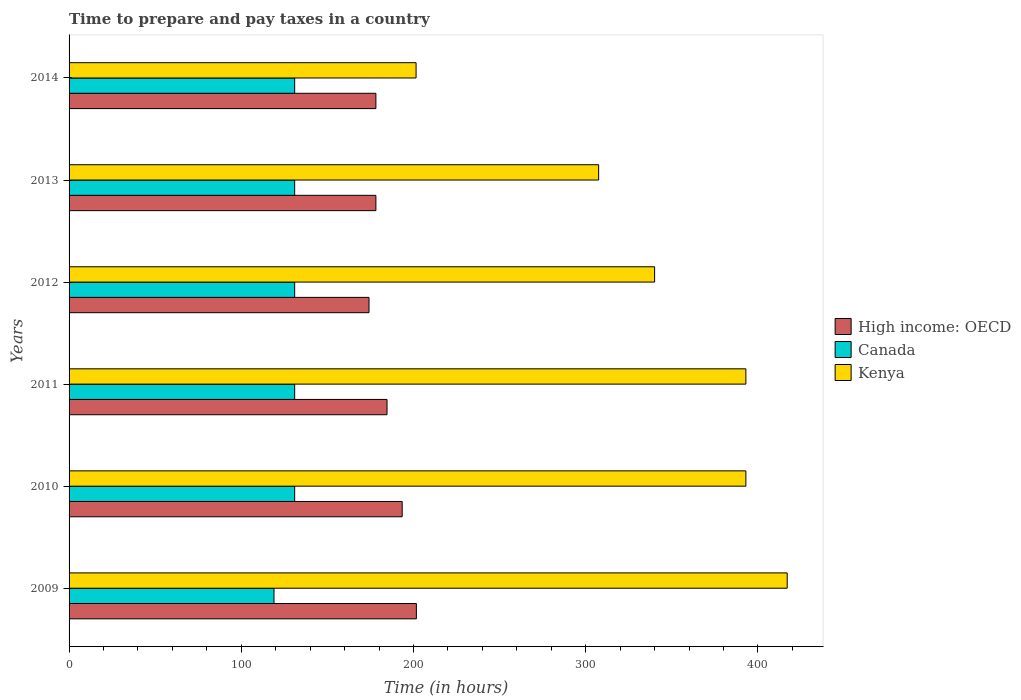How many groups of bars are there?
Ensure brevity in your answer.  6. How many bars are there on the 4th tick from the top?
Your response must be concise. 3. What is the number of hours required to prepare and pay taxes in High income: OECD in 2012?
Make the answer very short. 174.17. Across all years, what is the maximum number of hours required to prepare and pay taxes in High income: OECD?
Ensure brevity in your answer.  201.67. Across all years, what is the minimum number of hours required to prepare and pay taxes in High income: OECD?
Your answer should be very brief. 174.17. In which year was the number of hours required to prepare and pay taxes in Kenya maximum?
Your answer should be very brief. 2009. What is the total number of hours required to prepare and pay taxes in Kenya in the graph?
Offer a terse response. 2052. What is the difference between the number of hours required to prepare and pay taxes in High income: OECD in 2012 and that in 2014?
Provide a short and direct response. -3.99. What is the difference between the number of hours required to prepare and pay taxes in Canada in 2009 and the number of hours required to prepare and pay taxes in Kenya in 2011?
Provide a succinct answer. -274. What is the average number of hours required to prepare and pay taxes in Canada per year?
Give a very brief answer. 129. In the year 2013, what is the difference between the number of hours required to prepare and pay taxes in Canada and number of hours required to prepare and pay taxes in Kenya?
Give a very brief answer. -176.5. What is the ratio of the number of hours required to prepare and pay taxes in High income: OECD in 2009 to that in 2013?
Make the answer very short. 1.13. What is the difference between the highest and the second highest number of hours required to prepare and pay taxes in Canada?
Provide a succinct answer. 0. What is the difference between the highest and the lowest number of hours required to prepare and pay taxes in High income: OECD?
Ensure brevity in your answer.  27.5. In how many years, is the number of hours required to prepare and pay taxes in Kenya greater than the average number of hours required to prepare and pay taxes in Kenya taken over all years?
Provide a succinct answer. 3. Is the sum of the number of hours required to prepare and pay taxes in Kenya in 2011 and 2013 greater than the maximum number of hours required to prepare and pay taxes in High income: OECD across all years?
Your response must be concise. Yes. What does the 3rd bar from the top in 2009 represents?
Offer a terse response. High income: OECD. What does the 3rd bar from the bottom in 2013 represents?
Offer a terse response. Kenya. How many years are there in the graph?
Your answer should be compact. 6. What is the difference between two consecutive major ticks on the X-axis?
Offer a very short reply. 100. Are the values on the major ticks of X-axis written in scientific E-notation?
Give a very brief answer. No. Does the graph contain any zero values?
Give a very brief answer. No. Does the graph contain grids?
Provide a succinct answer. No. Where does the legend appear in the graph?
Your answer should be compact. Center right. How many legend labels are there?
Offer a very short reply. 3. What is the title of the graph?
Your answer should be compact. Time to prepare and pay taxes in a country. What is the label or title of the X-axis?
Provide a short and direct response. Time (in hours). What is the label or title of the Y-axis?
Your answer should be compact. Years. What is the Time (in hours) of High income: OECD in 2009?
Ensure brevity in your answer.  201.67. What is the Time (in hours) in Canada in 2009?
Offer a very short reply. 119. What is the Time (in hours) in Kenya in 2009?
Make the answer very short. 417. What is the Time (in hours) in High income: OECD in 2010?
Provide a short and direct response. 193.43. What is the Time (in hours) of Canada in 2010?
Provide a short and direct response. 131. What is the Time (in hours) in Kenya in 2010?
Provide a succinct answer. 393. What is the Time (in hours) of High income: OECD in 2011?
Give a very brief answer. 184.63. What is the Time (in hours) in Canada in 2011?
Your response must be concise. 131. What is the Time (in hours) of Kenya in 2011?
Ensure brevity in your answer.  393. What is the Time (in hours) in High income: OECD in 2012?
Your answer should be compact. 174.17. What is the Time (in hours) in Canada in 2012?
Your answer should be compact. 131. What is the Time (in hours) of Kenya in 2012?
Your response must be concise. 340. What is the Time (in hours) of High income: OECD in 2013?
Provide a short and direct response. 178.16. What is the Time (in hours) of Canada in 2013?
Keep it short and to the point. 131. What is the Time (in hours) of Kenya in 2013?
Your answer should be very brief. 307.5. What is the Time (in hours) of High income: OECD in 2014?
Your answer should be compact. 178.16. What is the Time (in hours) in Canada in 2014?
Your response must be concise. 131. What is the Time (in hours) of Kenya in 2014?
Provide a succinct answer. 201.5. Across all years, what is the maximum Time (in hours) in High income: OECD?
Provide a succinct answer. 201.67. Across all years, what is the maximum Time (in hours) of Canada?
Provide a short and direct response. 131. Across all years, what is the maximum Time (in hours) in Kenya?
Your response must be concise. 417. Across all years, what is the minimum Time (in hours) in High income: OECD?
Your response must be concise. 174.17. Across all years, what is the minimum Time (in hours) of Canada?
Provide a succinct answer. 119. Across all years, what is the minimum Time (in hours) in Kenya?
Offer a very short reply. 201.5. What is the total Time (in hours) of High income: OECD in the graph?
Offer a very short reply. 1110.21. What is the total Time (in hours) in Canada in the graph?
Offer a terse response. 774. What is the total Time (in hours) of Kenya in the graph?
Provide a succinct answer. 2052. What is the difference between the Time (in hours) of High income: OECD in 2009 and that in 2010?
Keep it short and to the point. 8.23. What is the difference between the Time (in hours) of Canada in 2009 and that in 2010?
Your answer should be compact. -12. What is the difference between the Time (in hours) in Kenya in 2009 and that in 2010?
Give a very brief answer. 24. What is the difference between the Time (in hours) of High income: OECD in 2009 and that in 2011?
Your answer should be compact. 17.03. What is the difference between the Time (in hours) in Canada in 2009 and that in 2011?
Your answer should be very brief. -12. What is the difference between the Time (in hours) of High income: OECD in 2009 and that in 2012?
Your answer should be very brief. 27.5. What is the difference between the Time (in hours) of Canada in 2009 and that in 2012?
Offer a very short reply. -12. What is the difference between the Time (in hours) in High income: OECD in 2009 and that in 2013?
Provide a short and direct response. 23.51. What is the difference between the Time (in hours) of Canada in 2009 and that in 2013?
Give a very brief answer. -12. What is the difference between the Time (in hours) in Kenya in 2009 and that in 2013?
Your answer should be very brief. 109.5. What is the difference between the Time (in hours) in High income: OECD in 2009 and that in 2014?
Ensure brevity in your answer.  23.51. What is the difference between the Time (in hours) of Canada in 2009 and that in 2014?
Provide a succinct answer. -12. What is the difference between the Time (in hours) of Kenya in 2009 and that in 2014?
Give a very brief answer. 215.5. What is the difference between the Time (in hours) of Kenya in 2010 and that in 2011?
Your answer should be compact. 0. What is the difference between the Time (in hours) in High income: OECD in 2010 and that in 2012?
Ensure brevity in your answer.  19.27. What is the difference between the Time (in hours) in Kenya in 2010 and that in 2012?
Keep it short and to the point. 53. What is the difference between the Time (in hours) in High income: OECD in 2010 and that in 2013?
Keep it short and to the point. 15.28. What is the difference between the Time (in hours) of Kenya in 2010 and that in 2013?
Your response must be concise. 85.5. What is the difference between the Time (in hours) of High income: OECD in 2010 and that in 2014?
Your response must be concise. 15.28. What is the difference between the Time (in hours) in Kenya in 2010 and that in 2014?
Your answer should be compact. 191.5. What is the difference between the Time (in hours) of High income: OECD in 2011 and that in 2012?
Offer a terse response. 10.47. What is the difference between the Time (in hours) of Kenya in 2011 and that in 2012?
Your response must be concise. 53. What is the difference between the Time (in hours) in High income: OECD in 2011 and that in 2013?
Give a very brief answer. 6.48. What is the difference between the Time (in hours) in Canada in 2011 and that in 2013?
Give a very brief answer. 0. What is the difference between the Time (in hours) in Kenya in 2011 and that in 2013?
Provide a short and direct response. 85.5. What is the difference between the Time (in hours) of High income: OECD in 2011 and that in 2014?
Provide a succinct answer. 6.48. What is the difference between the Time (in hours) of Canada in 2011 and that in 2014?
Offer a very short reply. 0. What is the difference between the Time (in hours) of Kenya in 2011 and that in 2014?
Offer a terse response. 191.5. What is the difference between the Time (in hours) in High income: OECD in 2012 and that in 2013?
Keep it short and to the point. -3.99. What is the difference between the Time (in hours) of Canada in 2012 and that in 2013?
Give a very brief answer. 0. What is the difference between the Time (in hours) of Kenya in 2012 and that in 2013?
Give a very brief answer. 32.5. What is the difference between the Time (in hours) of High income: OECD in 2012 and that in 2014?
Give a very brief answer. -3.99. What is the difference between the Time (in hours) in Canada in 2012 and that in 2014?
Offer a terse response. 0. What is the difference between the Time (in hours) in Kenya in 2012 and that in 2014?
Ensure brevity in your answer.  138.5. What is the difference between the Time (in hours) of High income: OECD in 2013 and that in 2014?
Provide a succinct answer. 0. What is the difference between the Time (in hours) in Canada in 2013 and that in 2014?
Your answer should be compact. 0. What is the difference between the Time (in hours) in Kenya in 2013 and that in 2014?
Make the answer very short. 106. What is the difference between the Time (in hours) in High income: OECD in 2009 and the Time (in hours) in Canada in 2010?
Your answer should be compact. 70.67. What is the difference between the Time (in hours) of High income: OECD in 2009 and the Time (in hours) of Kenya in 2010?
Keep it short and to the point. -191.33. What is the difference between the Time (in hours) in Canada in 2009 and the Time (in hours) in Kenya in 2010?
Keep it short and to the point. -274. What is the difference between the Time (in hours) in High income: OECD in 2009 and the Time (in hours) in Canada in 2011?
Offer a terse response. 70.67. What is the difference between the Time (in hours) in High income: OECD in 2009 and the Time (in hours) in Kenya in 2011?
Offer a terse response. -191.33. What is the difference between the Time (in hours) of Canada in 2009 and the Time (in hours) of Kenya in 2011?
Give a very brief answer. -274. What is the difference between the Time (in hours) of High income: OECD in 2009 and the Time (in hours) of Canada in 2012?
Offer a very short reply. 70.67. What is the difference between the Time (in hours) in High income: OECD in 2009 and the Time (in hours) in Kenya in 2012?
Your response must be concise. -138.33. What is the difference between the Time (in hours) of Canada in 2009 and the Time (in hours) of Kenya in 2012?
Ensure brevity in your answer.  -221. What is the difference between the Time (in hours) of High income: OECD in 2009 and the Time (in hours) of Canada in 2013?
Keep it short and to the point. 70.67. What is the difference between the Time (in hours) in High income: OECD in 2009 and the Time (in hours) in Kenya in 2013?
Ensure brevity in your answer.  -105.83. What is the difference between the Time (in hours) in Canada in 2009 and the Time (in hours) in Kenya in 2013?
Ensure brevity in your answer.  -188.5. What is the difference between the Time (in hours) of High income: OECD in 2009 and the Time (in hours) of Canada in 2014?
Offer a very short reply. 70.67. What is the difference between the Time (in hours) in High income: OECD in 2009 and the Time (in hours) in Kenya in 2014?
Offer a terse response. 0.17. What is the difference between the Time (in hours) in Canada in 2009 and the Time (in hours) in Kenya in 2014?
Ensure brevity in your answer.  -82.5. What is the difference between the Time (in hours) in High income: OECD in 2010 and the Time (in hours) in Canada in 2011?
Make the answer very short. 62.43. What is the difference between the Time (in hours) of High income: OECD in 2010 and the Time (in hours) of Kenya in 2011?
Provide a succinct answer. -199.57. What is the difference between the Time (in hours) of Canada in 2010 and the Time (in hours) of Kenya in 2011?
Offer a very short reply. -262. What is the difference between the Time (in hours) in High income: OECD in 2010 and the Time (in hours) in Canada in 2012?
Give a very brief answer. 62.43. What is the difference between the Time (in hours) in High income: OECD in 2010 and the Time (in hours) in Kenya in 2012?
Your answer should be very brief. -146.57. What is the difference between the Time (in hours) of Canada in 2010 and the Time (in hours) of Kenya in 2012?
Make the answer very short. -209. What is the difference between the Time (in hours) in High income: OECD in 2010 and the Time (in hours) in Canada in 2013?
Provide a succinct answer. 62.43. What is the difference between the Time (in hours) of High income: OECD in 2010 and the Time (in hours) of Kenya in 2013?
Provide a short and direct response. -114.07. What is the difference between the Time (in hours) in Canada in 2010 and the Time (in hours) in Kenya in 2013?
Ensure brevity in your answer.  -176.5. What is the difference between the Time (in hours) of High income: OECD in 2010 and the Time (in hours) of Canada in 2014?
Your answer should be very brief. 62.43. What is the difference between the Time (in hours) of High income: OECD in 2010 and the Time (in hours) of Kenya in 2014?
Ensure brevity in your answer.  -8.07. What is the difference between the Time (in hours) of Canada in 2010 and the Time (in hours) of Kenya in 2014?
Offer a terse response. -70.5. What is the difference between the Time (in hours) in High income: OECD in 2011 and the Time (in hours) in Canada in 2012?
Give a very brief answer. 53.63. What is the difference between the Time (in hours) in High income: OECD in 2011 and the Time (in hours) in Kenya in 2012?
Provide a short and direct response. -155.37. What is the difference between the Time (in hours) of Canada in 2011 and the Time (in hours) of Kenya in 2012?
Keep it short and to the point. -209. What is the difference between the Time (in hours) in High income: OECD in 2011 and the Time (in hours) in Canada in 2013?
Offer a very short reply. 53.63. What is the difference between the Time (in hours) in High income: OECD in 2011 and the Time (in hours) in Kenya in 2013?
Your answer should be very brief. -122.87. What is the difference between the Time (in hours) in Canada in 2011 and the Time (in hours) in Kenya in 2013?
Provide a succinct answer. -176.5. What is the difference between the Time (in hours) of High income: OECD in 2011 and the Time (in hours) of Canada in 2014?
Make the answer very short. 53.63. What is the difference between the Time (in hours) of High income: OECD in 2011 and the Time (in hours) of Kenya in 2014?
Make the answer very short. -16.87. What is the difference between the Time (in hours) in Canada in 2011 and the Time (in hours) in Kenya in 2014?
Your answer should be compact. -70.5. What is the difference between the Time (in hours) in High income: OECD in 2012 and the Time (in hours) in Canada in 2013?
Offer a very short reply. 43.17. What is the difference between the Time (in hours) of High income: OECD in 2012 and the Time (in hours) of Kenya in 2013?
Provide a short and direct response. -133.33. What is the difference between the Time (in hours) of Canada in 2012 and the Time (in hours) of Kenya in 2013?
Provide a succinct answer. -176.5. What is the difference between the Time (in hours) of High income: OECD in 2012 and the Time (in hours) of Canada in 2014?
Offer a terse response. 43.17. What is the difference between the Time (in hours) of High income: OECD in 2012 and the Time (in hours) of Kenya in 2014?
Your answer should be very brief. -27.33. What is the difference between the Time (in hours) in Canada in 2012 and the Time (in hours) in Kenya in 2014?
Provide a short and direct response. -70.5. What is the difference between the Time (in hours) of High income: OECD in 2013 and the Time (in hours) of Canada in 2014?
Ensure brevity in your answer.  47.16. What is the difference between the Time (in hours) of High income: OECD in 2013 and the Time (in hours) of Kenya in 2014?
Offer a very short reply. -23.34. What is the difference between the Time (in hours) of Canada in 2013 and the Time (in hours) of Kenya in 2014?
Keep it short and to the point. -70.5. What is the average Time (in hours) in High income: OECD per year?
Your answer should be very brief. 185.04. What is the average Time (in hours) of Canada per year?
Your answer should be compact. 129. What is the average Time (in hours) of Kenya per year?
Give a very brief answer. 342. In the year 2009, what is the difference between the Time (in hours) of High income: OECD and Time (in hours) of Canada?
Provide a succinct answer. 82.67. In the year 2009, what is the difference between the Time (in hours) of High income: OECD and Time (in hours) of Kenya?
Ensure brevity in your answer.  -215.33. In the year 2009, what is the difference between the Time (in hours) in Canada and Time (in hours) in Kenya?
Provide a succinct answer. -298. In the year 2010, what is the difference between the Time (in hours) in High income: OECD and Time (in hours) in Canada?
Your answer should be very brief. 62.43. In the year 2010, what is the difference between the Time (in hours) in High income: OECD and Time (in hours) in Kenya?
Your response must be concise. -199.57. In the year 2010, what is the difference between the Time (in hours) of Canada and Time (in hours) of Kenya?
Offer a terse response. -262. In the year 2011, what is the difference between the Time (in hours) of High income: OECD and Time (in hours) of Canada?
Your answer should be compact. 53.63. In the year 2011, what is the difference between the Time (in hours) of High income: OECD and Time (in hours) of Kenya?
Your response must be concise. -208.37. In the year 2011, what is the difference between the Time (in hours) in Canada and Time (in hours) in Kenya?
Provide a succinct answer. -262. In the year 2012, what is the difference between the Time (in hours) in High income: OECD and Time (in hours) in Canada?
Give a very brief answer. 43.17. In the year 2012, what is the difference between the Time (in hours) of High income: OECD and Time (in hours) of Kenya?
Your response must be concise. -165.83. In the year 2012, what is the difference between the Time (in hours) in Canada and Time (in hours) in Kenya?
Your answer should be very brief. -209. In the year 2013, what is the difference between the Time (in hours) of High income: OECD and Time (in hours) of Canada?
Offer a terse response. 47.16. In the year 2013, what is the difference between the Time (in hours) of High income: OECD and Time (in hours) of Kenya?
Make the answer very short. -129.34. In the year 2013, what is the difference between the Time (in hours) in Canada and Time (in hours) in Kenya?
Provide a short and direct response. -176.5. In the year 2014, what is the difference between the Time (in hours) in High income: OECD and Time (in hours) in Canada?
Keep it short and to the point. 47.16. In the year 2014, what is the difference between the Time (in hours) of High income: OECD and Time (in hours) of Kenya?
Provide a succinct answer. -23.34. In the year 2014, what is the difference between the Time (in hours) in Canada and Time (in hours) in Kenya?
Provide a succinct answer. -70.5. What is the ratio of the Time (in hours) in High income: OECD in 2009 to that in 2010?
Keep it short and to the point. 1.04. What is the ratio of the Time (in hours) in Canada in 2009 to that in 2010?
Provide a succinct answer. 0.91. What is the ratio of the Time (in hours) of Kenya in 2009 to that in 2010?
Your answer should be compact. 1.06. What is the ratio of the Time (in hours) of High income: OECD in 2009 to that in 2011?
Offer a terse response. 1.09. What is the ratio of the Time (in hours) in Canada in 2009 to that in 2011?
Your answer should be compact. 0.91. What is the ratio of the Time (in hours) in Kenya in 2009 to that in 2011?
Your response must be concise. 1.06. What is the ratio of the Time (in hours) of High income: OECD in 2009 to that in 2012?
Offer a terse response. 1.16. What is the ratio of the Time (in hours) in Canada in 2009 to that in 2012?
Keep it short and to the point. 0.91. What is the ratio of the Time (in hours) of Kenya in 2009 to that in 2012?
Provide a short and direct response. 1.23. What is the ratio of the Time (in hours) in High income: OECD in 2009 to that in 2013?
Provide a succinct answer. 1.13. What is the ratio of the Time (in hours) in Canada in 2009 to that in 2013?
Offer a terse response. 0.91. What is the ratio of the Time (in hours) of Kenya in 2009 to that in 2013?
Make the answer very short. 1.36. What is the ratio of the Time (in hours) in High income: OECD in 2009 to that in 2014?
Your answer should be very brief. 1.13. What is the ratio of the Time (in hours) in Canada in 2009 to that in 2014?
Offer a terse response. 0.91. What is the ratio of the Time (in hours) in Kenya in 2009 to that in 2014?
Offer a very short reply. 2.07. What is the ratio of the Time (in hours) of High income: OECD in 2010 to that in 2011?
Provide a succinct answer. 1.05. What is the ratio of the Time (in hours) in High income: OECD in 2010 to that in 2012?
Offer a very short reply. 1.11. What is the ratio of the Time (in hours) in Kenya in 2010 to that in 2012?
Offer a terse response. 1.16. What is the ratio of the Time (in hours) of High income: OECD in 2010 to that in 2013?
Make the answer very short. 1.09. What is the ratio of the Time (in hours) of Canada in 2010 to that in 2013?
Your answer should be compact. 1. What is the ratio of the Time (in hours) of Kenya in 2010 to that in 2013?
Keep it short and to the point. 1.28. What is the ratio of the Time (in hours) in High income: OECD in 2010 to that in 2014?
Make the answer very short. 1.09. What is the ratio of the Time (in hours) of Kenya in 2010 to that in 2014?
Provide a succinct answer. 1.95. What is the ratio of the Time (in hours) of High income: OECD in 2011 to that in 2012?
Your response must be concise. 1.06. What is the ratio of the Time (in hours) in Kenya in 2011 to that in 2012?
Make the answer very short. 1.16. What is the ratio of the Time (in hours) in High income: OECD in 2011 to that in 2013?
Give a very brief answer. 1.04. What is the ratio of the Time (in hours) in Canada in 2011 to that in 2013?
Your answer should be compact. 1. What is the ratio of the Time (in hours) in Kenya in 2011 to that in 2013?
Ensure brevity in your answer.  1.28. What is the ratio of the Time (in hours) of High income: OECD in 2011 to that in 2014?
Your answer should be compact. 1.04. What is the ratio of the Time (in hours) of Canada in 2011 to that in 2014?
Offer a very short reply. 1. What is the ratio of the Time (in hours) of Kenya in 2011 to that in 2014?
Your answer should be very brief. 1.95. What is the ratio of the Time (in hours) of High income: OECD in 2012 to that in 2013?
Ensure brevity in your answer.  0.98. What is the ratio of the Time (in hours) in Canada in 2012 to that in 2013?
Offer a very short reply. 1. What is the ratio of the Time (in hours) of Kenya in 2012 to that in 2013?
Give a very brief answer. 1.11. What is the ratio of the Time (in hours) of High income: OECD in 2012 to that in 2014?
Ensure brevity in your answer.  0.98. What is the ratio of the Time (in hours) of Kenya in 2012 to that in 2014?
Provide a succinct answer. 1.69. What is the ratio of the Time (in hours) in Kenya in 2013 to that in 2014?
Your answer should be very brief. 1.53. What is the difference between the highest and the second highest Time (in hours) of High income: OECD?
Provide a succinct answer. 8.23. What is the difference between the highest and the second highest Time (in hours) in Canada?
Your response must be concise. 0. What is the difference between the highest and the second highest Time (in hours) of Kenya?
Your answer should be compact. 24. What is the difference between the highest and the lowest Time (in hours) in High income: OECD?
Your response must be concise. 27.5. What is the difference between the highest and the lowest Time (in hours) of Canada?
Provide a succinct answer. 12. What is the difference between the highest and the lowest Time (in hours) of Kenya?
Your answer should be compact. 215.5. 